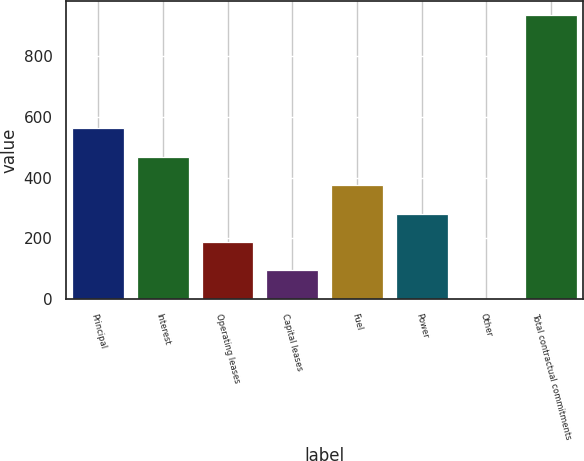Convert chart. <chart><loc_0><loc_0><loc_500><loc_500><bar_chart><fcel>Principal<fcel>Interest<fcel>Operating leases<fcel>Capital leases<fcel>Fuel<fcel>Power<fcel>Other<fcel>Total contractual commitments<nl><fcel>561.06<fcel>467.9<fcel>188.42<fcel>95.26<fcel>374.74<fcel>281.58<fcel>2.1<fcel>933.7<nl></chart> 